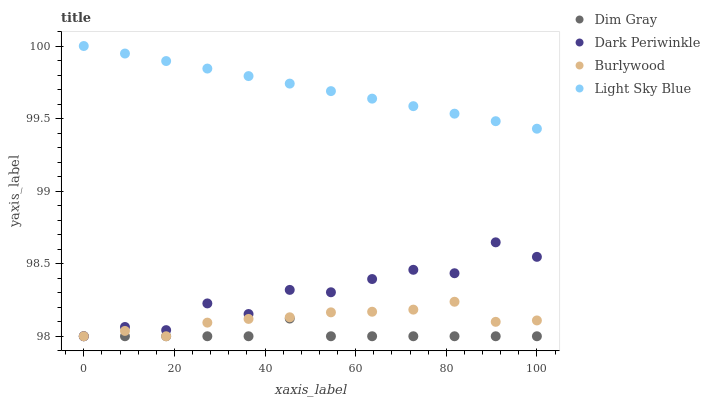Does Dim Gray have the minimum area under the curve?
Answer yes or no. Yes. Does Light Sky Blue have the maximum area under the curve?
Answer yes or no. Yes. Does Dark Periwinkle have the minimum area under the curve?
Answer yes or no. No. Does Dark Periwinkle have the maximum area under the curve?
Answer yes or no. No. Is Light Sky Blue the smoothest?
Answer yes or no. Yes. Is Dark Periwinkle the roughest?
Answer yes or no. Yes. Is Dim Gray the smoothest?
Answer yes or no. No. Is Dim Gray the roughest?
Answer yes or no. No. Does Burlywood have the lowest value?
Answer yes or no. Yes. Does Light Sky Blue have the lowest value?
Answer yes or no. No. Does Light Sky Blue have the highest value?
Answer yes or no. Yes. Does Dark Periwinkle have the highest value?
Answer yes or no. No. Is Dim Gray less than Light Sky Blue?
Answer yes or no. Yes. Is Light Sky Blue greater than Dark Periwinkle?
Answer yes or no. Yes. Does Burlywood intersect Dark Periwinkle?
Answer yes or no. Yes. Is Burlywood less than Dark Periwinkle?
Answer yes or no. No. Is Burlywood greater than Dark Periwinkle?
Answer yes or no. No. Does Dim Gray intersect Light Sky Blue?
Answer yes or no. No. 